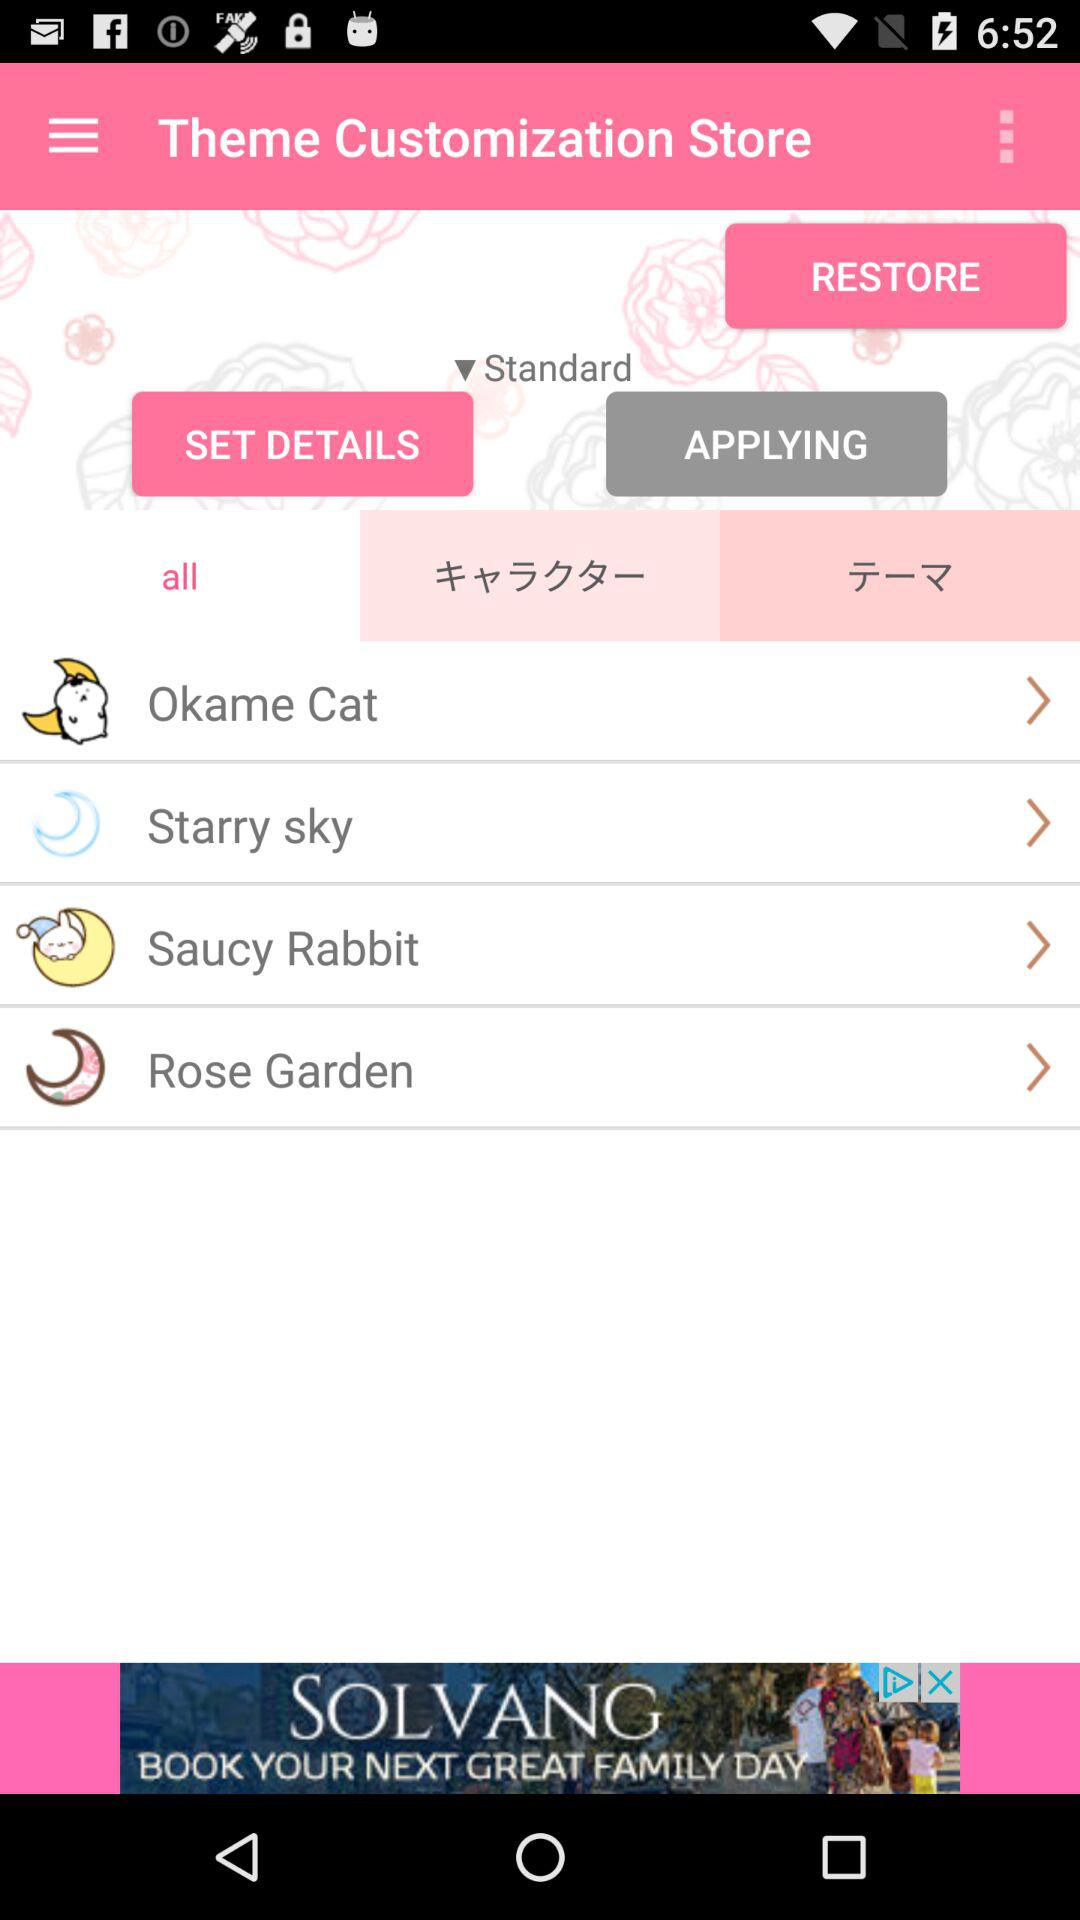What are the different categories of theme available? The different categories of theme available are: "Okame Cat", "Starry Sky", "Saucy Rabbit", and "Rose Garden". 